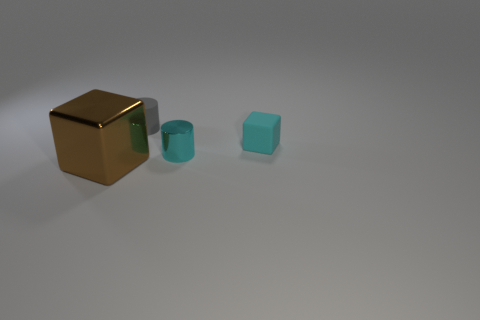Subtract all cyan blocks. How many blocks are left? 1 Add 3 small shiny cylinders. How many objects exist? 7 Subtract 1 cylinders. How many cylinders are left? 1 Subtract all brown shiny cubes. Subtract all tiny cyan cylinders. How many objects are left? 2 Add 1 small cyan cubes. How many small cyan cubes are left? 2 Add 3 brown blocks. How many brown blocks exist? 4 Subtract 0 red cubes. How many objects are left? 4 Subtract all yellow blocks. Subtract all brown spheres. How many blocks are left? 2 